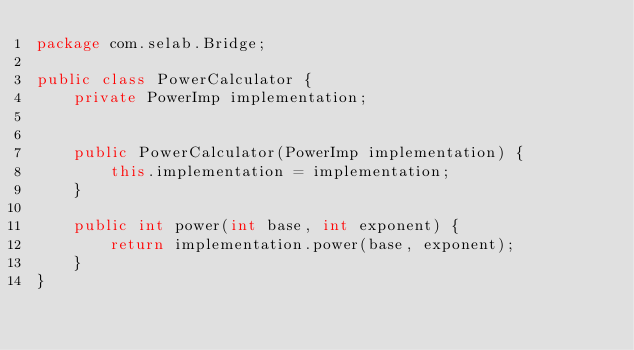<code> <loc_0><loc_0><loc_500><loc_500><_Java_>package com.selab.Bridge;

public class PowerCalculator {
    private PowerImp implementation;


    public PowerCalculator(PowerImp implementation) {
        this.implementation = implementation;
    }

    public int power(int base, int exponent) {
        return implementation.power(base, exponent);
    }
}
</code> 